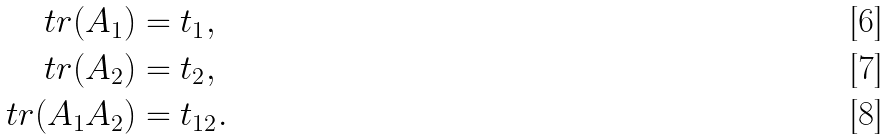<formula> <loc_0><loc_0><loc_500><loc_500>\ t r ( A _ { 1 } ) & = t _ { 1 } , \\ \ t r ( A _ { 2 } ) & = t _ { 2 } , \\ \ t r ( A _ { 1 } A _ { 2 } ) & = t _ { 1 2 } .</formula> 